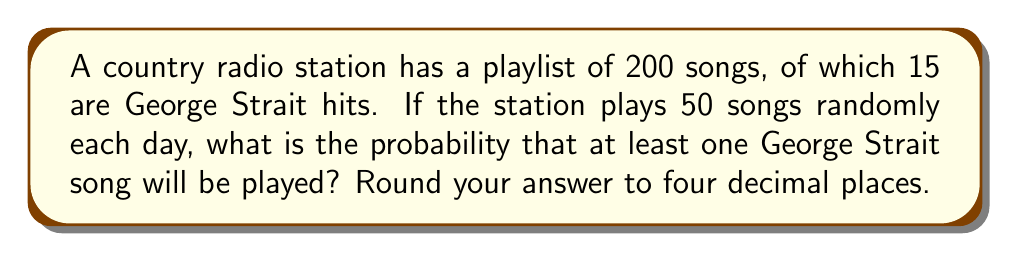Teach me how to tackle this problem. Let's approach this step-by-step:

1) First, let's consider the probability of not playing a George Strait song in a single selection:

   $P(\text{not George Strait}) = \frac{185}{200} = 0.925$

2) Now, for 50 selections, we want the probability of not playing any George Strait songs:

   $P(\text{no George Strait in 50 selections}) = (0.925)^{50}$

3) We can calculate this:

   $(0.925)^{50} \approx 0.0178$

4) The probability we're looking for is the opposite of this - the probability of playing at least one George Strait song:

   $P(\text{at least one George Strait}) = 1 - P(\text{no George Strait in 50 selections})$

5) Therefore:

   $P(\text{at least one George Strait}) = 1 - 0.0178 = 0.9822$

6) Rounding to four decimal places:

   $0.9822 \approx 0.9822$

This high probability would surely make any George Strait fan club president smile!
Answer: $0.9822$ 